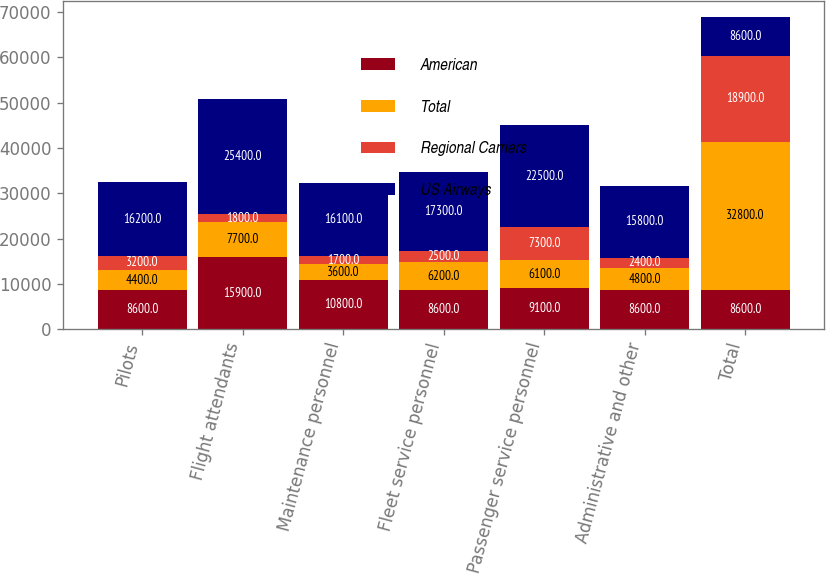Convert chart to OTSL. <chart><loc_0><loc_0><loc_500><loc_500><stacked_bar_chart><ecel><fcel>Pilots<fcel>Flight attendants<fcel>Maintenance personnel<fcel>Fleet service personnel<fcel>Passenger service personnel<fcel>Administrative and other<fcel>Total<nl><fcel>American<fcel>8600<fcel>15900<fcel>10800<fcel>8600<fcel>9100<fcel>8600<fcel>8600<nl><fcel>Total<fcel>4400<fcel>7700<fcel>3600<fcel>6200<fcel>6100<fcel>4800<fcel>32800<nl><fcel>Regional Carriers<fcel>3200<fcel>1800<fcel>1700<fcel>2500<fcel>7300<fcel>2400<fcel>18900<nl><fcel>US Airways<fcel>16200<fcel>25400<fcel>16100<fcel>17300<fcel>22500<fcel>15800<fcel>8600<nl></chart> 